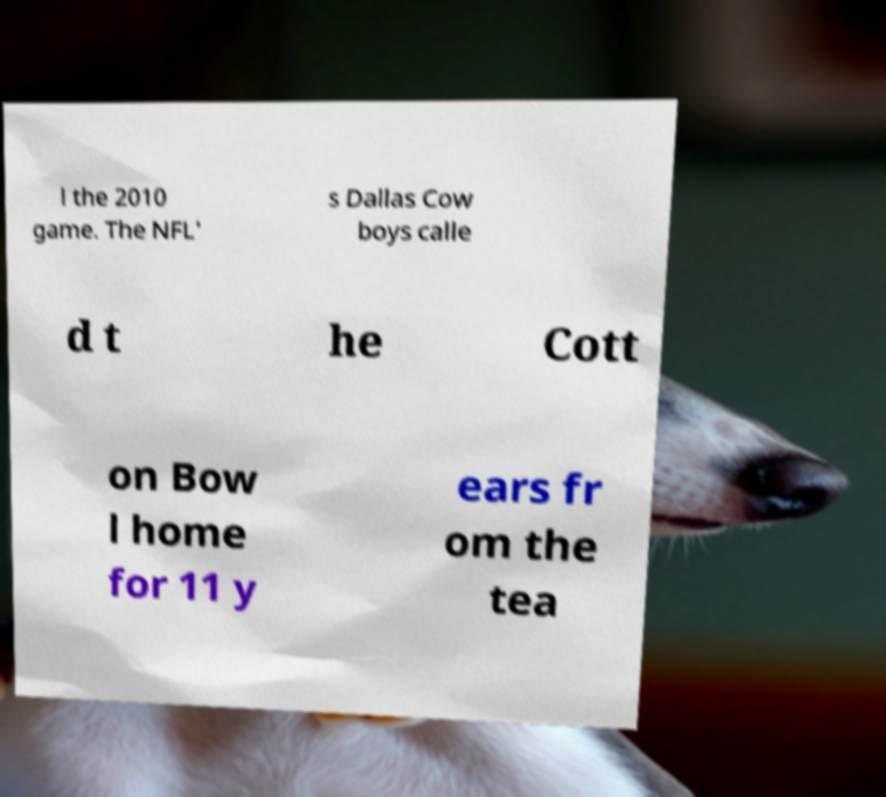Could you assist in decoding the text presented in this image and type it out clearly? l the 2010 game. The NFL' s Dallas Cow boys calle d t he Cott on Bow l home for 11 y ears fr om the tea 